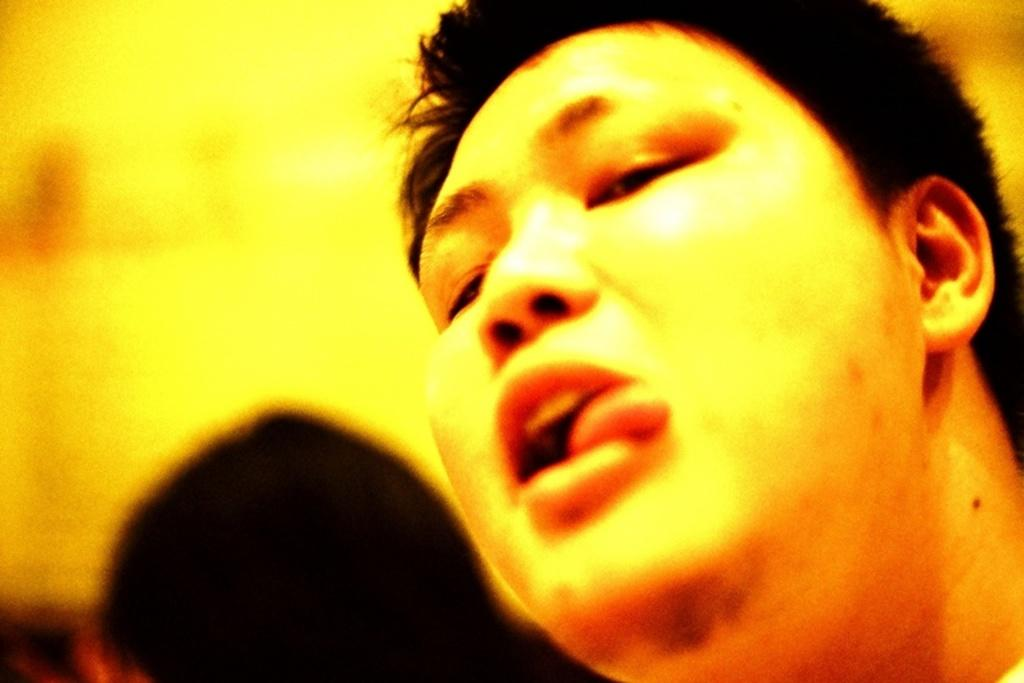What is the main subject of the image? There is a person's face in the image. What color is the background of the image? The background of the image is yellow. What type of polish is being applied to the person's face in the image? There is no indication of any polish being applied to the person's face in the image. 